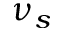<formula> <loc_0><loc_0><loc_500><loc_500>\nu _ { s }</formula> 